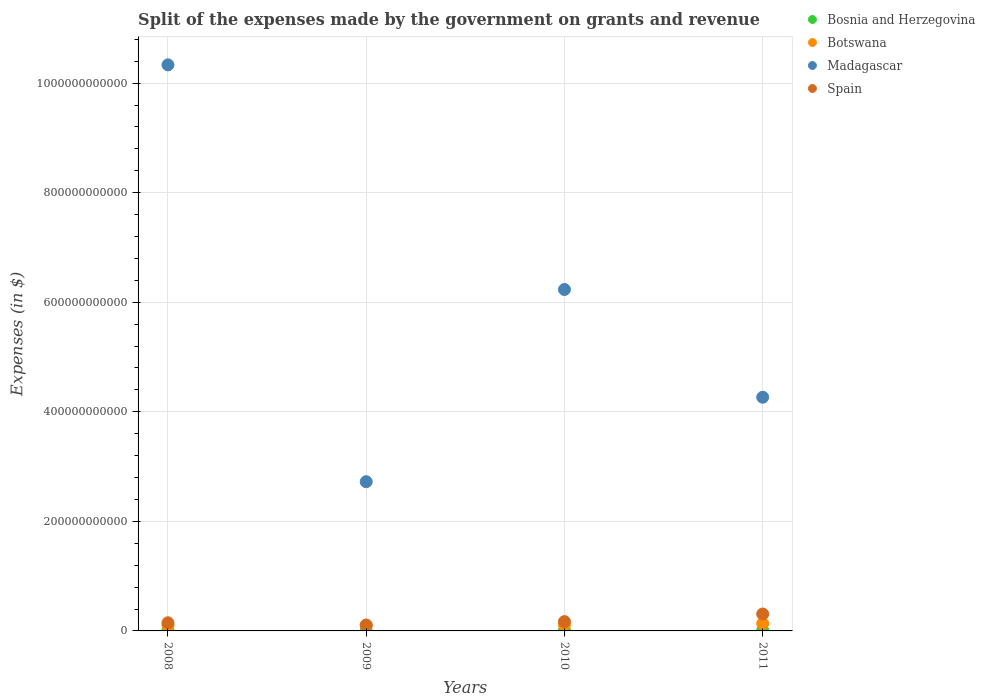What is the expenses made by the government on grants and revenue in Madagascar in 2010?
Provide a succinct answer. 6.23e+11. Across all years, what is the maximum expenses made by the government on grants and revenue in Spain?
Ensure brevity in your answer.  3.08e+1. Across all years, what is the minimum expenses made by the government on grants and revenue in Madagascar?
Provide a succinct answer. 2.72e+11. What is the total expenses made by the government on grants and revenue in Spain in the graph?
Provide a short and direct response. 7.35e+1. What is the difference between the expenses made by the government on grants and revenue in Botswana in 2008 and that in 2009?
Offer a very short reply. 1.95e+07. What is the difference between the expenses made by the government on grants and revenue in Spain in 2008 and the expenses made by the government on grants and revenue in Madagascar in 2009?
Offer a very short reply. -2.58e+11. What is the average expenses made by the government on grants and revenue in Spain per year?
Your answer should be compact. 1.84e+1. In the year 2010, what is the difference between the expenses made by the government on grants and revenue in Madagascar and expenses made by the government on grants and revenue in Botswana?
Your answer should be very brief. 6.12e+11. In how many years, is the expenses made by the government on grants and revenue in Madagascar greater than 360000000000 $?
Provide a succinct answer. 3. What is the ratio of the expenses made by the government on grants and revenue in Spain in 2010 to that in 2011?
Make the answer very short. 0.55. Is the expenses made by the government on grants and revenue in Bosnia and Herzegovina in 2008 less than that in 2010?
Your answer should be very brief. Yes. What is the difference between the highest and the second highest expenses made by the government on grants and revenue in Botswana?
Your answer should be compact. 2.20e+09. What is the difference between the highest and the lowest expenses made by the government on grants and revenue in Botswana?
Provide a short and direct response. 3.66e+09. Is it the case that in every year, the sum of the expenses made by the government on grants and revenue in Botswana and expenses made by the government on grants and revenue in Madagascar  is greater than the sum of expenses made by the government on grants and revenue in Spain and expenses made by the government on grants and revenue in Bosnia and Herzegovina?
Provide a succinct answer. Yes. Is it the case that in every year, the sum of the expenses made by the government on grants and revenue in Spain and expenses made by the government on grants and revenue in Madagascar  is greater than the expenses made by the government on grants and revenue in Botswana?
Make the answer very short. Yes. How many dotlines are there?
Provide a short and direct response. 4. What is the difference between two consecutive major ticks on the Y-axis?
Your response must be concise. 2.00e+11. Are the values on the major ticks of Y-axis written in scientific E-notation?
Your answer should be compact. No. Where does the legend appear in the graph?
Keep it short and to the point. Top right. How many legend labels are there?
Keep it short and to the point. 4. What is the title of the graph?
Make the answer very short. Split of the expenses made by the government on grants and revenue. What is the label or title of the Y-axis?
Ensure brevity in your answer.  Expenses (in $). What is the Expenses (in $) of Bosnia and Herzegovina in 2008?
Offer a very short reply. 9.49e+08. What is the Expenses (in $) of Botswana in 2008?
Your answer should be compact. 9.89e+09. What is the Expenses (in $) in Madagascar in 2008?
Your response must be concise. 1.03e+12. What is the Expenses (in $) of Spain in 2008?
Offer a terse response. 1.49e+1. What is the Expenses (in $) of Bosnia and Herzegovina in 2009?
Offer a terse response. 1.02e+09. What is the Expenses (in $) of Botswana in 2009?
Provide a succinct answer. 9.87e+09. What is the Expenses (in $) of Madagascar in 2009?
Give a very brief answer. 2.72e+11. What is the Expenses (in $) in Spain in 2009?
Make the answer very short. 1.08e+1. What is the Expenses (in $) in Bosnia and Herzegovina in 2010?
Offer a terse response. 9.70e+08. What is the Expenses (in $) of Botswana in 2010?
Offer a very short reply. 1.13e+1. What is the Expenses (in $) of Madagascar in 2010?
Your answer should be compact. 6.23e+11. What is the Expenses (in $) of Spain in 2010?
Ensure brevity in your answer.  1.70e+1. What is the Expenses (in $) of Bosnia and Herzegovina in 2011?
Your response must be concise. 8.87e+08. What is the Expenses (in $) of Botswana in 2011?
Offer a terse response. 1.35e+1. What is the Expenses (in $) in Madagascar in 2011?
Offer a terse response. 4.27e+11. What is the Expenses (in $) of Spain in 2011?
Ensure brevity in your answer.  3.08e+1. Across all years, what is the maximum Expenses (in $) of Bosnia and Herzegovina?
Provide a short and direct response. 1.02e+09. Across all years, what is the maximum Expenses (in $) of Botswana?
Offer a terse response. 1.35e+1. Across all years, what is the maximum Expenses (in $) of Madagascar?
Provide a short and direct response. 1.03e+12. Across all years, what is the maximum Expenses (in $) of Spain?
Offer a terse response. 3.08e+1. Across all years, what is the minimum Expenses (in $) of Bosnia and Herzegovina?
Provide a succinct answer. 8.87e+08. Across all years, what is the minimum Expenses (in $) of Botswana?
Offer a terse response. 9.87e+09. Across all years, what is the minimum Expenses (in $) in Madagascar?
Your response must be concise. 2.72e+11. Across all years, what is the minimum Expenses (in $) of Spain?
Offer a terse response. 1.08e+1. What is the total Expenses (in $) in Bosnia and Herzegovina in the graph?
Give a very brief answer. 3.83e+09. What is the total Expenses (in $) in Botswana in the graph?
Offer a terse response. 4.46e+1. What is the total Expenses (in $) in Madagascar in the graph?
Give a very brief answer. 2.36e+12. What is the total Expenses (in $) in Spain in the graph?
Make the answer very short. 7.35e+1. What is the difference between the Expenses (in $) in Bosnia and Herzegovina in 2008 and that in 2009?
Your answer should be very brief. -7.27e+07. What is the difference between the Expenses (in $) in Botswana in 2008 and that in 2009?
Your answer should be compact. 1.95e+07. What is the difference between the Expenses (in $) in Madagascar in 2008 and that in 2009?
Give a very brief answer. 7.61e+11. What is the difference between the Expenses (in $) in Spain in 2008 and that in 2009?
Your answer should be very brief. 4.06e+09. What is the difference between the Expenses (in $) of Bosnia and Herzegovina in 2008 and that in 2010?
Provide a short and direct response. -2.06e+07. What is the difference between the Expenses (in $) of Botswana in 2008 and that in 2010?
Offer a very short reply. -1.44e+09. What is the difference between the Expenses (in $) in Madagascar in 2008 and that in 2010?
Make the answer very short. 4.10e+11. What is the difference between the Expenses (in $) of Spain in 2008 and that in 2010?
Your answer should be compact. -2.12e+09. What is the difference between the Expenses (in $) of Bosnia and Herzegovina in 2008 and that in 2011?
Offer a very short reply. 6.24e+07. What is the difference between the Expenses (in $) of Botswana in 2008 and that in 2011?
Keep it short and to the point. -3.64e+09. What is the difference between the Expenses (in $) in Madagascar in 2008 and that in 2011?
Keep it short and to the point. 6.07e+11. What is the difference between the Expenses (in $) in Spain in 2008 and that in 2011?
Offer a very short reply. -1.60e+1. What is the difference between the Expenses (in $) in Bosnia and Herzegovina in 2009 and that in 2010?
Your answer should be very brief. 5.21e+07. What is the difference between the Expenses (in $) in Botswana in 2009 and that in 2010?
Offer a very short reply. -1.46e+09. What is the difference between the Expenses (in $) of Madagascar in 2009 and that in 2010?
Ensure brevity in your answer.  -3.51e+11. What is the difference between the Expenses (in $) of Spain in 2009 and that in 2010?
Your response must be concise. -6.18e+09. What is the difference between the Expenses (in $) in Bosnia and Herzegovina in 2009 and that in 2011?
Provide a succinct answer. 1.35e+08. What is the difference between the Expenses (in $) in Botswana in 2009 and that in 2011?
Provide a succinct answer. -3.66e+09. What is the difference between the Expenses (in $) in Madagascar in 2009 and that in 2011?
Make the answer very short. -1.54e+11. What is the difference between the Expenses (in $) of Spain in 2009 and that in 2011?
Offer a terse response. -2.00e+1. What is the difference between the Expenses (in $) in Bosnia and Herzegovina in 2010 and that in 2011?
Your response must be concise. 8.30e+07. What is the difference between the Expenses (in $) of Botswana in 2010 and that in 2011?
Give a very brief answer. -2.20e+09. What is the difference between the Expenses (in $) of Madagascar in 2010 and that in 2011?
Ensure brevity in your answer.  1.97e+11. What is the difference between the Expenses (in $) in Spain in 2010 and that in 2011?
Offer a terse response. -1.39e+1. What is the difference between the Expenses (in $) of Bosnia and Herzegovina in 2008 and the Expenses (in $) of Botswana in 2009?
Provide a succinct answer. -8.93e+09. What is the difference between the Expenses (in $) in Bosnia and Herzegovina in 2008 and the Expenses (in $) in Madagascar in 2009?
Ensure brevity in your answer.  -2.71e+11. What is the difference between the Expenses (in $) in Bosnia and Herzegovina in 2008 and the Expenses (in $) in Spain in 2009?
Offer a very short reply. -9.85e+09. What is the difference between the Expenses (in $) of Botswana in 2008 and the Expenses (in $) of Madagascar in 2009?
Your response must be concise. -2.63e+11. What is the difference between the Expenses (in $) in Botswana in 2008 and the Expenses (in $) in Spain in 2009?
Give a very brief answer. -9.07e+08. What is the difference between the Expenses (in $) of Madagascar in 2008 and the Expenses (in $) of Spain in 2009?
Your response must be concise. 1.02e+12. What is the difference between the Expenses (in $) in Bosnia and Herzegovina in 2008 and the Expenses (in $) in Botswana in 2010?
Ensure brevity in your answer.  -1.04e+1. What is the difference between the Expenses (in $) in Bosnia and Herzegovina in 2008 and the Expenses (in $) in Madagascar in 2010?
Your answer should be very brief. -6.22e+11. What is the difference between the Expenses (in $) in Bosnia and Herzegovina in 2008 and the Expenses (in $) in Spain in 2010?
Offer a very short reply. -1.60e+1. What is the difference between the Expenses (in $) in Botswana in 2008 and the Expenses (in $) in Madagascar in 2010?
Your answer should be very brief. -6.13e+11. What is the difference between the Expenses (in $) of Botswana in 2008 and the Expenses (in $) of Spain in 2010?
Your answer should be very brief. -7.09e+09. What is the difference between the Expenses (in $) in Madagascar in 2008 and the Expenses (in $) in Spain in 2010?
Keep it short and to the point. 1.02e+12. What is the difference between the Expenses (in $) of Bosnia and Herzegovina in 2008 and the Expenses (in $) of Botswana in 2011?
Your response must be concise. -1.26e+1. What is the difference between the Expenses (in $) in Bosnia and Herzegovina in 2008 and the Expenses (in $) in Madagascar in 2011?
Offer a terse response. -4.26e+11. What is the difference between the Expenses (in $) of Bosnia and Herzegovina in 2008 and the Expenses (in $) of Spain in 2011?
Ensure brevity in your answer.  -2.99e+1. What is the difference between the Expenses (in $) of Botswana in 2008 and the Expenses (in $) of Madagascar in 2011?
Give a very brief answer. -4.17e+11. What is the difference between the Expenses (in $) of Botswana in 2008 and the Expenses (in $) of Spain in 2011?
Your response must be concise. -2.10e+1. What is the difference between the Expenses (in $) in Madagascar in 2008 and the Expenses (in $) in Spain in 2011?
Give a very brief answer. 1.00e+12. What is the difference between the Expenses (in $) in Bosnia and Herzegovina in 2009 and the Expenses (in $) in Botswana in 2010?
Provide a succinct answer. -1.03e+1. What is the difference between the Expenses (in $) in Bosnia and Herzegovina in 2009 and the Expenses (in $) in Madagascar in 2010?
Ensure brevity in your answer.  -6.22e+11. What is the difference between the Expenses (in $) of Bosnia and Herzegovina in 2009 and the Expenses (in $) of Spain in 2010?
Your answer should be compact. -1.60e+1. What is the difference between the Expenses (in $) in Botswana in 2009 and the Expenses (in $) in Madagascar in 2010?
Your answer should be very brief. -6.13e+11. What is the difference between the Expenses (in $) of Botswana in 2009 and the Expenses (in $) of Spain in 2010?
Your answer should be very brief. -7.11e+09. What is the difference between the Expenses (in $) in Madagascar in 2009 and the Expenses (in $) in Spain in 2010?
Keep it short and to the point. 2.55e+11. What is the difference between the Expenses (in $) in Bosnia and Herzegovina in 2009 and the Expenses (in $) in Botswana in 2011?
Provide a short and direct response. -1.25e+1. What is the difference between the Expenses (in $) of Bosnia and Herzegovina in 2009 and the Expenses (in $) of Madagascar in 2011?
Give a very brief answer. -4.26e+11. What is the difference between the Expenses (in $) in Bosnia and Herzegovina in 2009 and the Expenses (in $) in Spain in 2011?
Your response must be concise. -2.98e+1. What is the difference between the Expenses (in $) in Botswana in 2009 and the Expenses (in $) in Madagascar in 2011?
Your answer should be very brief. -4.17e+11. What is the difference between the Expenses (in $) in Botswana in 2009 and the Expenses (in $) in Spain in 2011?
Offer a very short reply. -2.10e+1. What is the difference between the Expenses (in $) of Madagascar in 2009 and the Expenses (in $) of Spain in 2011?
Offer a very short reply. 2.42e+11. What is the difference between the Expenses (in $) of Bosnia and Herzegovina in 2010 and the Expenses (in $) of Botswana in 2011?
Offer a very short reply. -1.26e+1. What is the difference between the Expenses (in $) in Bosnia and Herzegovina in 2010 and the Expenses (in $) in Madagascar in 2011?
Keep it short and to the point. -4.26e+11. What is the difference between the Expenses (in $) in Bosnia and Herzegovina in 2010 and the Expenses (in $) in Spain in 2011?
Keep it short and to the point. -2.99e+1. What is the difference between the Expenses (in $) in Botswana in 2010 and the Expenses (in $) in Madagascar in 2011?
Provide a short and direct response. -4.15e+11. What is the difference between the Expenses (in $) in Botswana in 2010 and the Expenses (in $) in Spain in 2011?
Keep it short and to the point. -1.95e+1. What is the difference between the Expenses (in $) of Madagascar in 2010 and the Expenses (in $) of Spain in 2011?
Offer a very short reply. 5.92e+11. What is the average Expenses (in $) in Bosnia and Herzegovina per year?
Offer a very short reply. 9.57e+08. What is the average Expenses (in $) of Botswana per year?
Offer a very short reply. 1.12e+1. What is the average Expenses (in $) of Madagascar per year?
Give a very brief answer. 5.89e+11. What is the average Expenses (in $) of Spain per year?
Provide a short and direct response. 1.84e+1. In the year 2008, what is the difference between the Expenses (in $) in Bosnia and Herzegovina and Expenses (in $) in Botswana?
Give a very brief answer. -8.94e+09. In the year 2008, what is the difference between the Expenses (in $) in Bosnia and Herzegovina and Expenses (in $) in Madagascar?
Your answer should be compact. -1.03e+12. In the year 2008, what is the difference between the Expenses (in $) in Bosnia and Herzegovina and Expenses (in $) in Spain?
Your answer should be compact. -1.39e+1. In the year 2008, what is the difference between the Expenses (in $) in Botswana and Expenses (in $) in Madagascar?
Your answer should be compact. -1.02e+12. In the year 2008, what is the difference between the Expenses (in $) in Botswana and Expenses (in $) in Spain?
Your response must be concise. -4.96e+09. In the year 2008, what is the difference between the Expenses (in $) of Madagascar and Expenses (in $) of Spain?
Make the answer very short. 1.02e+12. In the year 2009, what is the difference between the Expenses (in $) of Bosnia and Herzegovina and Expenses (in $) of Botswana?
Your answer should be compact. -8.85e+09. In the year 2009, what is the difference between the Expenses (in $) of Bosnia and Herzegovina and Expenses (in $) of Madagascar?
Ensure brevity in your answer.  -2.71e+11. In the year 2009, what is the difference between the Expenses (in $) in Bosnia and Herzegovina and Expenses (in $) in Spain?
Provide a short and direct response. -9.78e+09. In the year 2009, what is the difference between the Expenses (in $) of Botswana and Expenses (in $) of Madagascar?
Provide a short and direct response. -2.63e+11. In the year 2009, what is the difference between the Expenses (in $) in Botswana and Expenses (in $) in Spain?
Your response must be concise. -9.27e+08. In the year 2009, what is the difference between the Expenses (in $) of Madagascar and Expenses (in $) of Spain?
Ensure brevity in your answer.  2.62e+11. In the year 2010, what is the difference between the Expenses (in $) of Bosnia and Herzegovina and Expenses (in $) of Botswana?
Make the answer very short. -1.04e+1. In the year 2010, what is the difference between the Expenses (in $) in Bosnia and Herzegovina and Expenses (in $) in Madagascar?
Ensure brevity in your answer.  -6.22e+11. In the year 2010, what is the difference between the Expenses (in $) of Bosnia and Herzegovina and Expenses (in $) of Spain?
Provide a succinct answer. -1.60e+1. In the year 2010, what is the difference between the Expenses (in $) of Botswana and Expenses (in $) of Madagascar?
Your answer should be compact. -6.12e+11. In the year 2010, what is the difference between the Expenses (in $) in Botswana and Expenses (in $) in Spain?
Provide a short and direct response. -5.65e+09. In the year 2010, what is the difference between the Expenses (in $) in Madagascar and Expenses (in $) in Spain?
Offer a terse response. 6.06e+11. In the year 2011, what is the difference between the Expenses (in $) in Bosnia and Herzegovina and Expenses (in $) in Botswana?
Offer a terse response. -1.26e+1. In the year 2011, what is the difference between the Expenses (in $) of Bosnia and Herzegovina and Expenses (in $) of Madagascar?
Your answer should be very brief. -4.26e+11. In the year 2011, what is the difference between the Expenses (in $) of Bosnia and Herzegovina and Expenses (in $) of Spain?
Keep it short and to the point. -3.00e+1. In the year 2011, what is the difference between the Expenses (in $) in Botswana and Expenses (in $) in Madagascar?
Offer a very short reply. -4.13e+11. In the year 2011, what is the difference between the Expenses (in $) of Botswana and Expenses (in $) of Spain?
Keep it short and to the point. -1.73e+1. In the year 2011, what is the difference between the Expenses (in $) in Madagascar and Expenses (in $) in Spain?
Provide a succinct answer. 3.96e+11. What is the ratio of the Expenses (in $) in Bosnia and Herzegovina in 2008 to that in 2009?
Give a very brief answer. 0.93. What is the ratio of the Expenses (in $) in Botswana in 2008 to that in 2009?
Your answer should be very brief. 1. What is the ratio of the Expenses (in $) in Madagascar in 2008 to that in 2009?
Your answer should be very brief. 3.79. What is the ratio of the Expenses (in $) in Spain in 2008 to that in 2009?
Give a very brief answer. 1.38. What is the ratio of the Expenses (in $) in Bosnia and Herzegovina in 2008 to that in 2010?
Provide a short and direct response. 0.98. What is the ratio of the Expenses (in $) in Botswana in 2008 to that in 2010?
Provide a short and direct response. 0.87. What is the ratio of the Expenses (in $) in Madagascar in 2008 to that in 2010?
Your response must be concise. 1.66. What is the ratio of the Expenses (in $) of Spain in 2008 to that in 2010?
Offer a very short reply. 0.87. What is the ratio of the Expenses (in $) of Bosnia and Herzegovina in 2008 to that in 2011?
Your response must be concise. 1.07. What is the ratio of the Expenses (in $) in Botswana in 2008 to that in 2011?
Keep it short and to the point. 0.73. What is the ratio of the Expenses (in $) of Madagascar in 2008 to that in 2011?
Ensure brevity in your answer.  2.42. What is the ratio of the Expenses (in $) of Spain in 2008 to that in 2011?
Keep it short and to the point. 0.48. What is the ratio of the Expenses (in $) in Bosnia and Herzegovina in 2009 to that in 2010?
Give a very brief answer. 1.05. What is the ratio of the Expenses (in $) in Botswana in 2009 to that in 2010?
Your answer should be compact. 0.87. What is the ratio of the Expenses (in $) in Madagascar in 2009 to that in 2010?
Your answer should be very brief. 0.44. What is the ratio of the Expenses (in $) in Spain in 2009 to that in 2010?
Your answer should be compact. 0.64. What is the ratio of the Expenses (in $) of Bosnia and Herzegovina in 2009 to that in 2011?
Give a very brief answer. 1.15. What is the ratio of the Expenses (in $) in Botswana in 2009 to that in 2011?
Ensure brevity in your answer.  0.73. What is the ratio of the Expenses (in $) in Madagascar in 2009 to that in 2011?
Give a very brief answer. 0.64. What is the ratio of the Expenses (in $) in Spain in 2009 to that in 2011?
Offer a very short reply. 0.35. What is the ratio of the Expenses (in $) of Bosnia and Herzegovina in 2010 to that in 2011?
Your response must be concise. 1.09. What is the ratio of the Expenses (in $) of Botswana in 2010 to that in 2011?
Keep it short and to the point. 0.84. What is the ratio of the Expenses (in $) in Madagascar in 2010 to that in 2011?
Your response must be concise. 1.46. What is the ratio of the Expenses (in $) in Spain in 2010 to that in 2011?
Offer a very short reply. 0.55. What is the difference between the highest and the second highest Expenses (in $) in Bosnia and Herzegovina?
Provide a short and direct response. 5.21e+07. What is the difference between the highest and the second highest Expenses (in $) of Botswana?
Your answer should be compact. 2.20e+09. What is the difference between the highest and the second highest Expenses (in $) of Madagascar?
Ensure brevity in your answer.  4.10e+11. What is the difference between the highest and the second highest Expenses (in $) in Spain?
Your response must be concise. 1.39e+1. What is the difference between the highest and the lowest Expenses (in $) in Bosnia and Herzegovina?
Give a very brief answer. 1.35e+08. What is the difference between the highest and the lowest Expenses (in $) in Botswana?
Your answer should be very brief. 3.66e+09. What is the difference between the highest and the lowest Expenses (in $) in Madagascar?
Your response must be concise. 7.61e+11. What is the difference between the highest and the lowest Expenses (in $) in Spain?
Your response must be concise. 2.00e+1. 